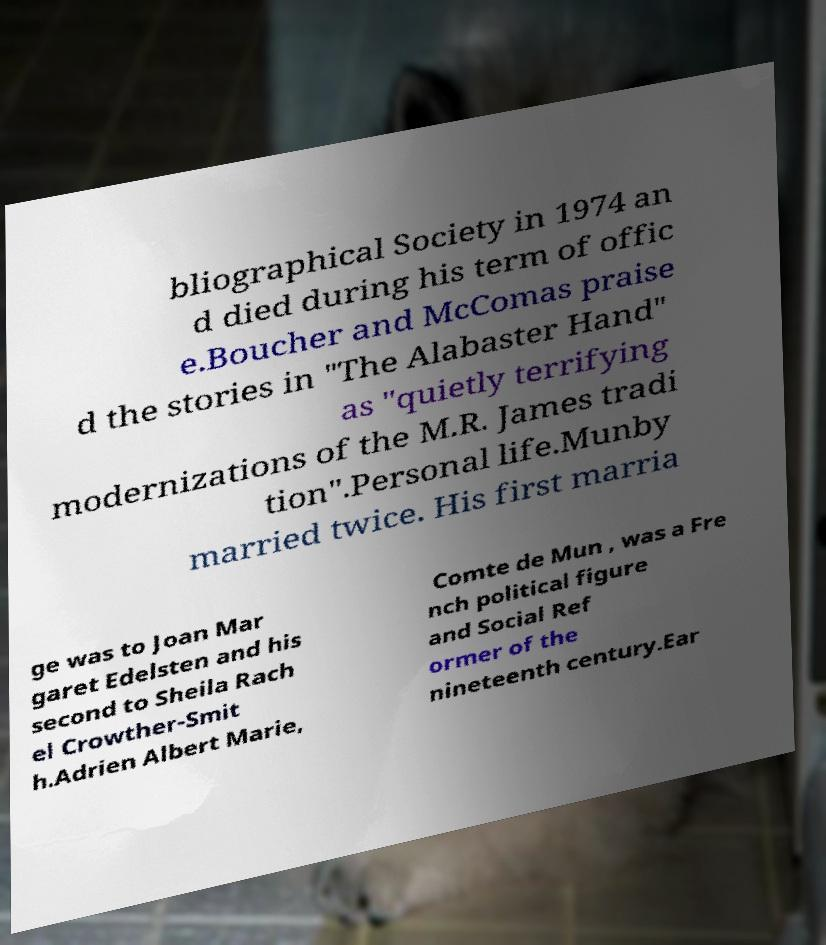There's text embedded in this image that I need extracted. Can you transcribe it verbatim? bliographical Society in 1974 an d died during his term of offic e.Boucher and McComas praise d the stories in "The Alabaster Hand" as "quietly terrifying modernizations of the M.R. James tradi tion".Personal life.Munby married twice. His first marria ge was to Joan Mar garet Edelsten and his second to Sheila Rach el Crowther-Smit h.Adrien Albert Marie, Comte de Mun , was a Fre nch political figure and Social Ref ormer of the nineteenth century.Ear 